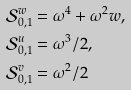<formula> <loc_0><loc_0><loc_500><loc_500>\mathcal { S } _ { 0 , 1 } ^ { w } & = \omega ^ { 4 } + \omega ^ { 2 } w , \\ \mathcal { S } _ { 0 , 1 } ^ { u } & = \omega ^ { 3 } / 2 , \\ \mathcal { S } _ { 0 , 1 } ^ { v } & = \omega ^ { 2 } / 2</formula> 